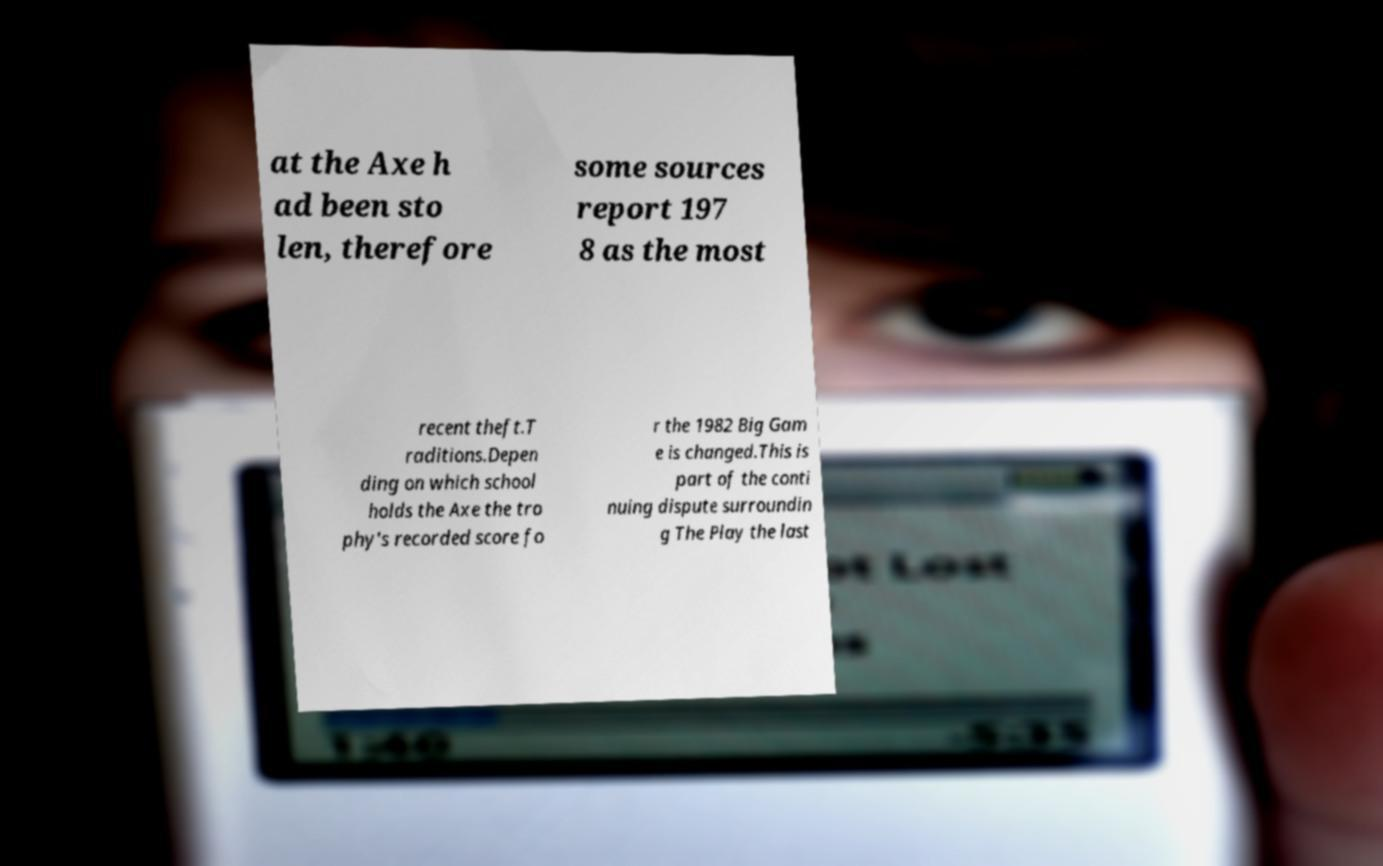For documentation purposes, I need the text within this image transcribed. Could you provide that? at the Axe h ad been sto len, therefore some sources report 197 8 as the most recent theft.T raditions.Depen ding on which school holds the Axe the tro phy's recorded score fo r the 1982 Big Gam e is changed.This is part of the conti nuing dispute surroundin g The Play the last 